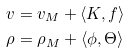<formula> <loc_0><loc_0><loc_500><loc_500>v & = v _ { M } + \langle K , f \rangle \\ \rho & = \rho _ { M } + \langle \phi , \Theta \rangle</formula> 